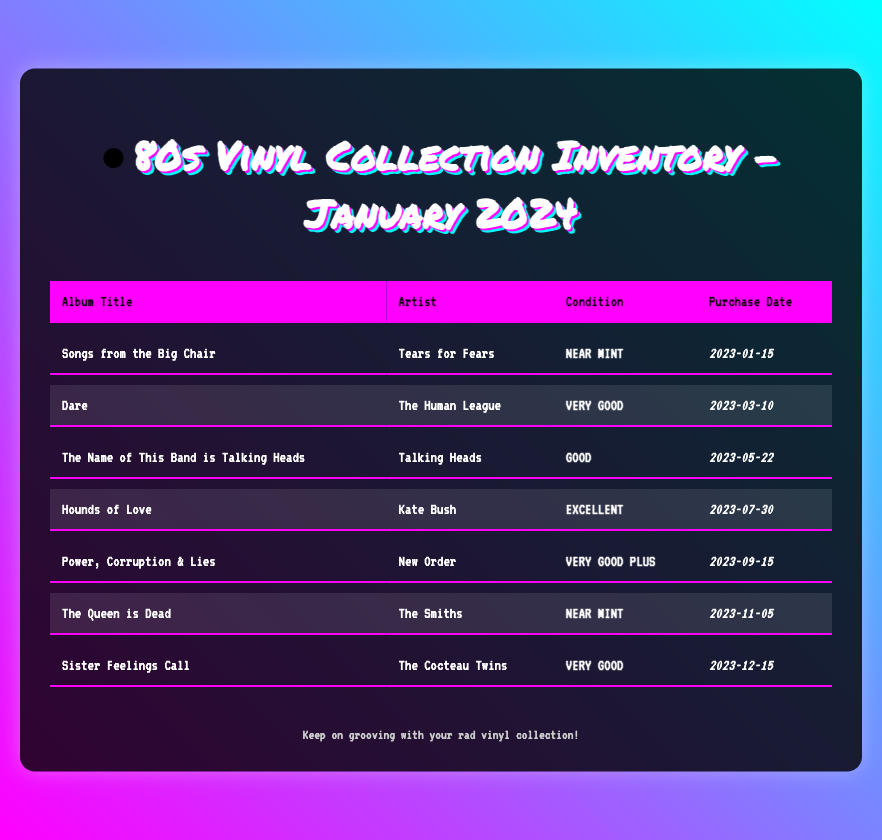What is the title of the first album? The first album listed in the inventory is "Songs from the Big Chair".
Answer: Songs from the Big Chair Who is the artist of "Dare"? The artist of the album "Dare" is The Human League.
Answer: The Human League What condition is "Hounds of Love" rated? The condition rating for "Hounds of Love" is Excellent.
Answer: Excellent On what date was "The Queen is Dead" purchased? "The Queen is Dead" was purchased on November 5, 2023.
Answer: 2023-11-05 How many albums have a condition rating of "Very Good"? There are two albums rated as "Very Good".
Answer: 2 Which artist has two albums listed in the inventory? The artist that appears with two albums in the inventory is The Cocteau Twins.
Answer: The Cocteau Twins What is the most recent purchase date in the inventory? The most recent purchase date listed is December 15, 2023.
Answer: 2023-12-15 Which album has the lowest condition rating? The album with the lowest condition rating is "The Name of This Band is Talking Heads".
Answer: The Name of This Band is Talking Heads What album was released by Kate Bush? The album released by Kate Bush listed in the inventory is "Hounds of Love".
Answer: Hounds of Love 